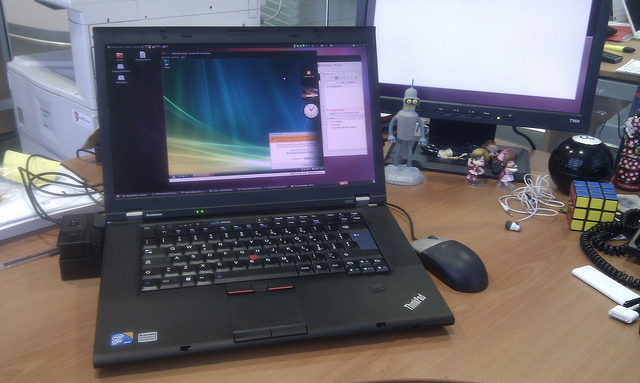<image>Behind the computer on the right is a statue of what cartoon character? I am not sure what cartoon character is behind the computer on the right. It can be a statue of 'wally', 'robot', 'knight', 'bender', 'alien' or 'robot'. Behind the computer on the right is a statue of what cartoon character? I don't know behind the computer on the right is a statue of what cartoon character. It can be seen 'wally', 'robot', 'knight', 'bender' or 'alien'. 